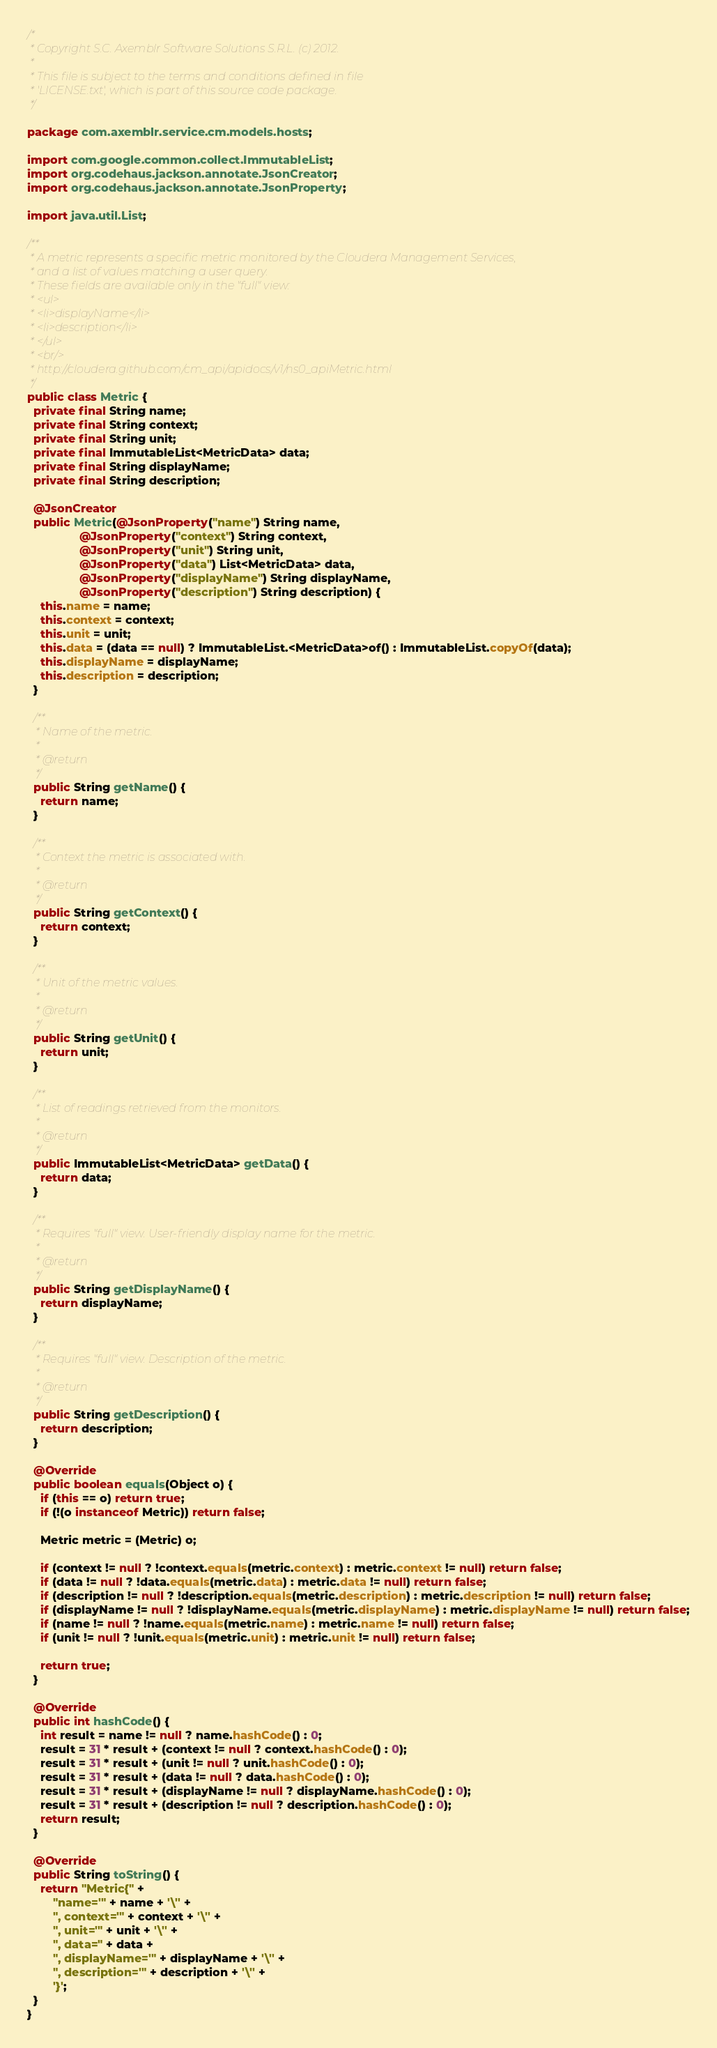<code> <loc_0><loc_0><loc_500><loc_500><_Java_>/*
 * Copyright S.C. Axemblr Software Solutions S.R.L. (c) 2012.
 *
 * This file is subject to the terms and conditions defined in file
 * 'LICENSE.txt', which is part of this source code package.
 */

package com.axemblr.service.cm.models.hosts;

import com.google.common.collect.ImmutableList;
import org.codehaus.jackson.annotate.JsonCreator;
import org.codehaus.jackson.annotate.JsonProperty;

import java.util.List;

/**
 * A metric represents a specific metric monitored by the Cloudera Management Services,
 * and a list of values matching a user query.
 * These fields are available only in the "full" view:
 * <ul>
 * <li>displayName</li>
 * <li>description</li>
 * </ul>
 * <br/>
 * http://cloudera.github.com/cm_api/apidocs/v1/ns0_apiMetric.html
 */
public class Metric {
  private final String name;
  private final String context;
  private final String unit;
  private final ImmutableList<MetricData> data;
  private final String displayName;
  private final String description;

  @JsonCreator
  public Metric(@JsonProperty("name") String name,
                @JsonProperty("context") String context,
                @JsonProperty("unit") String unit,
                @JsonProperty("data") List<MetricData> data,
                @JsonProperty("displayName") String displayName,
                @JsonProperty("description") String description) {
    this.name = name;
    this.context = context;
    this.unit = unit;
    this.data = (data == null) ? ImmutableList.<MetricData>of() : ImmutableList.copyOf(data);
    this.displayName = displayName;
    this.description = description;
  }

  /**
   * Name of the metric.
   *
   * @return
   */
  public String getName() {
    return name;
  }

  /**
   * Context the metric is associated with.
   *
   * @return
   */
  public String getContext() {
    return context;
  }

  /**
   * Unit of the metric values.
   *
   * @return
   */
  public String getUnit() {
    return unit;
  }

  /**
   * List of readings retrieved from the monitors.
   *
   * @return
   */
  public ImmutableList<MetricData> getData() {
    return data;
  }

  /**
   * Requires "full" view. User-friendly display name for the metric.
   *
   * @return
   */
  public String getDisplayName() {
    return displayName;
  }

  /**
   * Requires "full" view. Description of the metric.
   *
   * @return
   */
  public String getDescription() {
    return description;
  }

  @Override
  public boolean equals(Object o) {
    if (this == o) return true;
    if (!(o instanceof Metric)) return false;

    Metric metric = (Metric) o;

    if (context != null ? !context.equals(metric.context) : metric.context != null) return false;
    if (data != null ? !data.equals(metric.data) : metric.data != null) return false;
    if (description != null ? !description.equals(metric.description) : metric.description != null) return false;
    if (displayName != null ? !displayName.equals(metric.displayName) : metric.displayName != null) return false;
    if (name != null ? !name.equals(metric.name) : metric.name != null) return false;
    if (unit != null ? !unit.equals(metric.unit) : metric.unit != null) return false;

    return true;
  }

  @Override
  public int hashCode() {
    int result = name != null ? name.hashCode() : 0;
    result = 31 * result + (context != null ? context.hashCode() : 0);
    result = 31 * result + (unit != null ? unit.hashCode() : 0);
    result = 31 * result + (data != null ? data.hashCode() : 0);
    result = 31 * result + (displayName != null ? displayName.hashCode() : 0);
    result = 31 * result + (description != null ? description.hashCode() : 0);
    return result;
  }

  @Override
  public String toString() {
    return "Metric{" +
        "name='" + name + '\'' +
        ", context='" + context + '\'' +
        ", unit='" + unit + '\'' +
        ", data=" + data +
        ", displayName='" + displayName + '\'' +
        ", description='" + description + '\'' +
        '}';
  }
}
</code> 